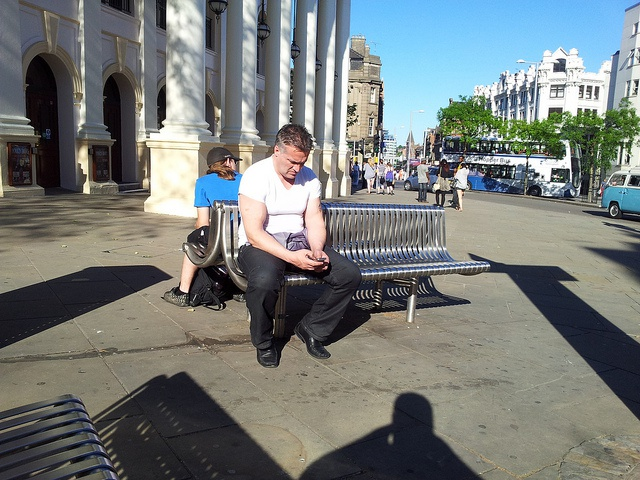Describe the objects in this image and their specific colors. I can see people in gray, black, white, and lightpink tones, bench in gray, darkgray, black, and lightgray tones, bench in gray and black tones, bus in gray, black, white, and darkgray tones, and people in gray, lightblue, lightgray, and black tones in this image. 